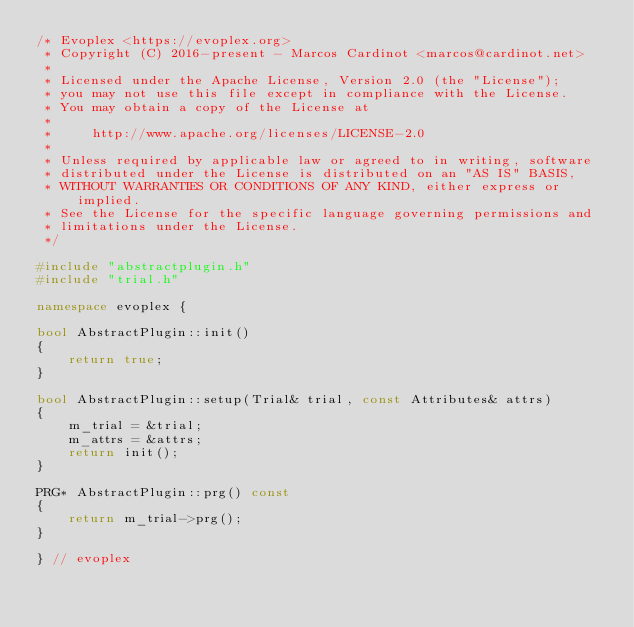<code> <loc_0><loc_0><loc_500><loc_500><_C++_>/* Evoplex <https://evoplex.org>
 * Copyright (C) 2016-present - Marcos Cardinot <marcos@cardinot.net>
 *
 * Licensed under the Apache License, Version 2.0 (the "License");
 * you may not use this file except in compliance with the License.
 * You may obtain a copy of the License at
 *
 *     http://www.apache.org/licenses/LICENSE-2.0
 *
 * Unless required by applicable law or agreed to in writing, software
 * distributed under the License is distributed on an "AS IS" BASIS,
 * WITHOUT WARRANTIES OR CONDITIONS OF ANY KIND, either express or implied.
 * See the License for the specific language governing permissions and
 * limitations under the License.
 */

#include "abstractplugin.h"
#include "trial.h"

namespace evoplex {

bool AbstractPlugin::init()
{
    return true;
}

bool AbstractPlugin::setup(Trial& trial, const Attributes& attrs)
{
    m_trial = &trial;
    m_attrs = &attrs;
    return init();
}

PRG* AbstractPlugin::prg() const
{
    return m_trial->prg();
}

} // evoplex
</code> 